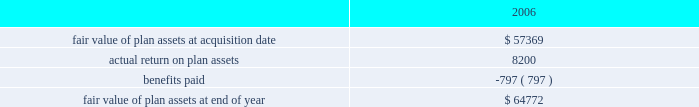For the valuation of the 4199466 performance-based options granted in 2005 : the risk free interest rate was 4.2% ( 4.2 % ) , the volatility factor for the expected market price of the common stock was 44% ( 44 % ) , the expected dividend yield was zero and the objective time to exercise was 4.7 years with an objective in the money assumption of 2.95 years .
It was also expected that the initial public offering assumption would occur within a 9 month period from grant date .
The fair value of the performance-based options was calculated to be $ 5.85 .
The fair value for fis options granted in 2006 was estimated at the date of grant using a black-scholes option- pricing model with the following weighted average assumptions .
The risk free interest rates used in the calculation are the rate that corresponds to the weighted average expected life of an option .
The risk free interest rate used for options granted during 2006 was 4.9% ( 4.9 % ) .
A volatility factor for the expected market price of the common stock of 30% ( 30 % ) was used for options granted in 2006 .
The expected dividend yield used for 2006 was 0.5% ( 0.5 % ) .
A weighted average expected life of 6.4 years was used for 2006 .
The weighted average fair value of each option granted during 2006 was $ 15.52 .
At december 31 , 2006 , the total unrecognized compensation cost related to non-vested stock option grants is $ 86.1 million , which is expected to be recognized in pre-tax income over a weighted average period of 1.9 years .
The company intends to limit dilution caused by option exercises , including anticipated exercises , by repurchasing shares on the open market or in privately negotiated transactions .
During 2006 , the company repurchased 4261200 shares at an average price of $ 37.60 .
On october 25 , 2006 , the company 2019s board of directors approved a plan authorizing the repurchase of up to an additional $ 200 million worth of the company 2019s common stock .
Defined benefit plans certegy pension plan in connection with the certegy merger , the company announced that it will terminate and settle the certegy u.s .
Retirement income plan ( usrip ) .
The estimated impact of this settlement was reflected in the purchase price allocation as an increase in the pension liability , less the fair value of the pension plan assets , based on estimates of the total cost to settle the liability through the purchase of annuity contracts or lump sum settlements to the beneficiaries .
The final settlement will not occur until after an irs determination has been obtained , which is expected to be received in 2007 .
In addition to the net pension plan obligation of $ 21.6 million , the company assumed liabilities of $ 8.0 million for certegy 2019s supplemental executive retirement plan ( 201cserp 201d ) and $ 3.0 mil- lion for a postretirement benefit plan .
A reconciliation of the changes in the fair value of plan assets of the usrip for the period from february 1 , 2006 through december 31 , 2006 is as follows ( in thousands ) : .
Benefits paid in the above table include only those amounts paid directly from plan assets .
As of december 31 , 2006 and for 2007 through the pay out of the pension liability , the assets are being invested in u.s .
Treasury bonds due to the short duration until final payment .
Fidelity national information services , inc .
And subsidiaries and affiliates consolidated and combined financial statements notes to consolidated and combined financial statements 2014 ( continued ) .
What is the total cash spent for the repurchase of shares during 2006 , ( in millions ) ? 
Computations: ((4261200 * 37.60) / 1000000)
Answer: 160.22112. 